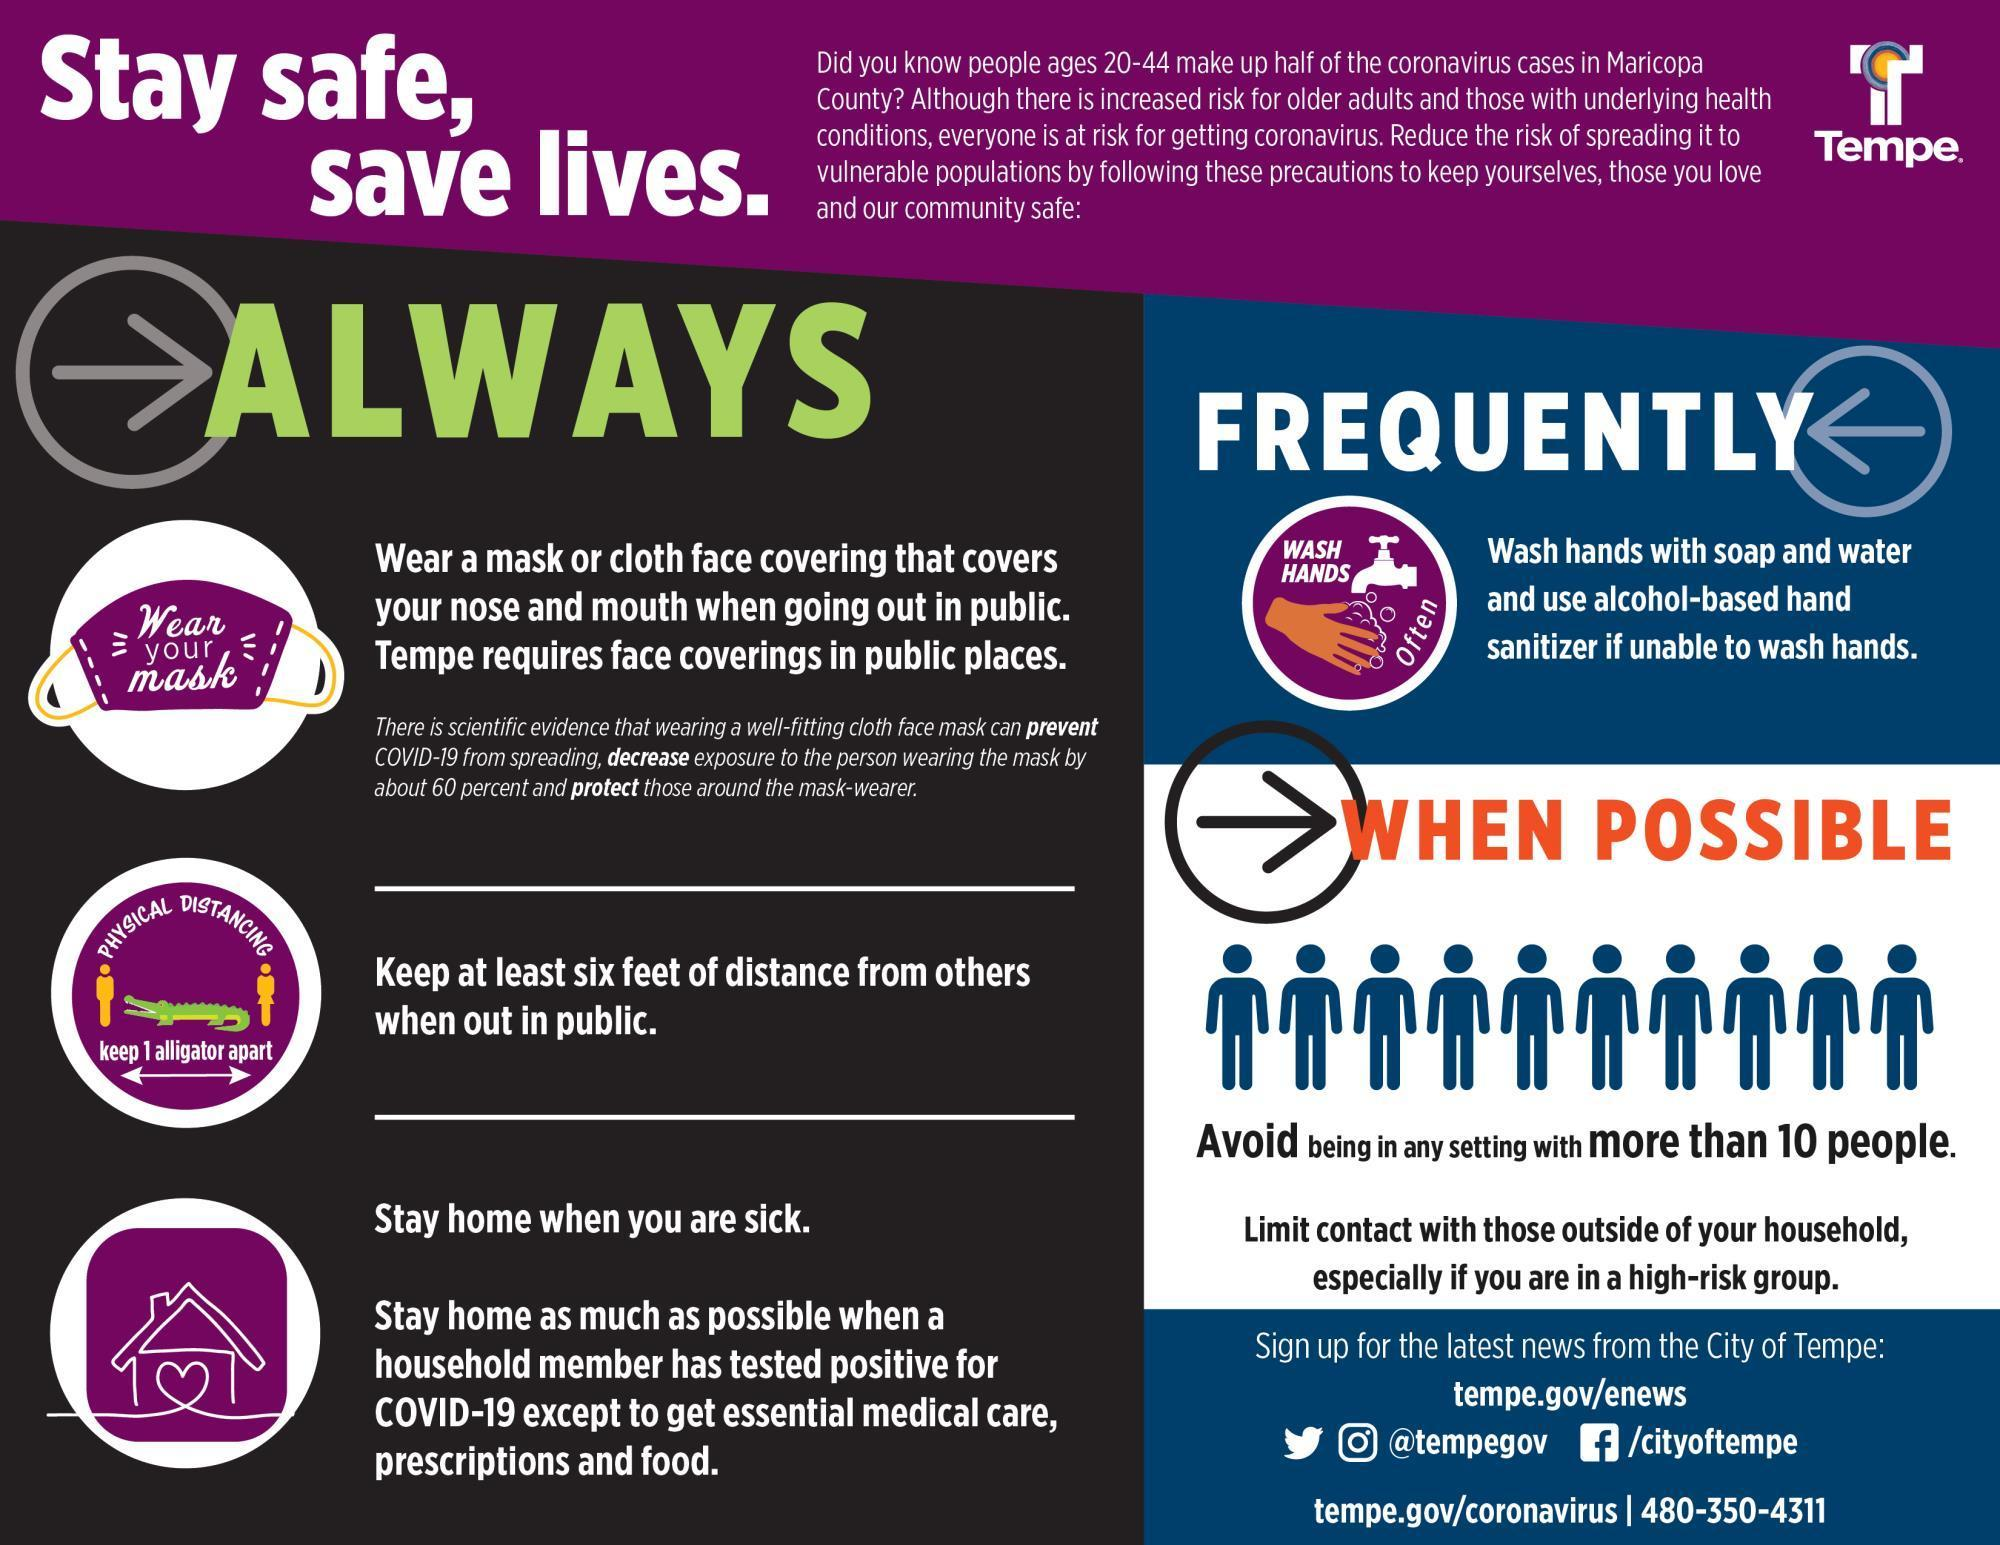What is the length of an alligator?
Answer the question with a short phrase. 6 feet 